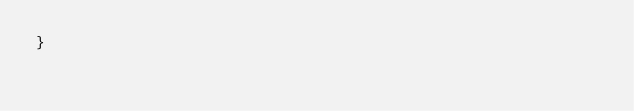<code> <loc_0><loc_0><loc_500><loc_500><_CSS_>}
</code> 